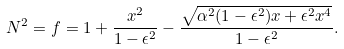<formula> <loc_0><loc_0><loc_500><loc_500>N ^ { 2 } = f = 1 + \frac { x ^ { 2 } } { 1 - \epsilon ^ { 2 } } - \frac { \sqrt { \alpha ^ { 2 } ( 1 - \epsilon ^ { 2 } ) x + \epsilon ^ { 2 } x ^ { 4 } } } { 1 - \epsilon ^ { 2 } } .</formula> 